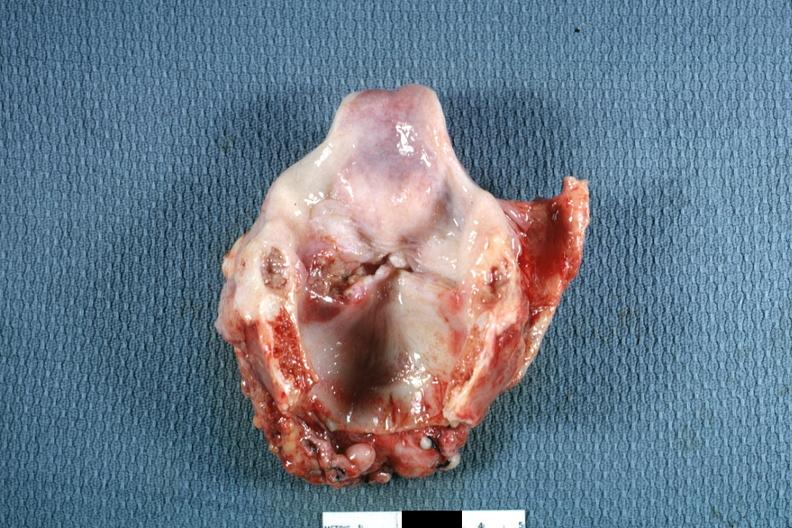what is present?
Answer the question using a single word or phrase. Larynx 